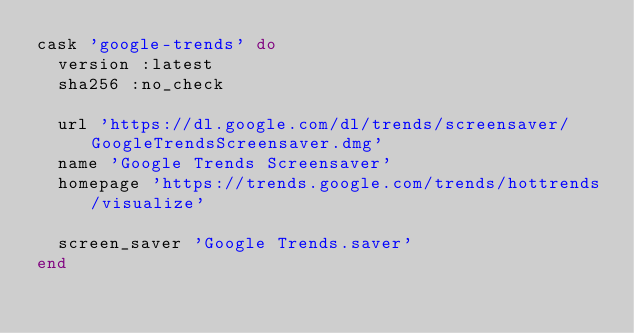Convert code to text. <code><loc_0><loc_0><loc_500><loc_500><_Ruby_>cask 'google-trends' do
  version :latest
  sha256 :no_check

  url 'https://dl.google.com/dl/trends/screensaver/GoogleTrendsScreensaver.dmg'
  name 'Google Trends Screensaver'
  homepage 'https://trends.google.com/trends/hottrends/visualize'

  screen_saver 'Google Trends.saver'
end
</code> 